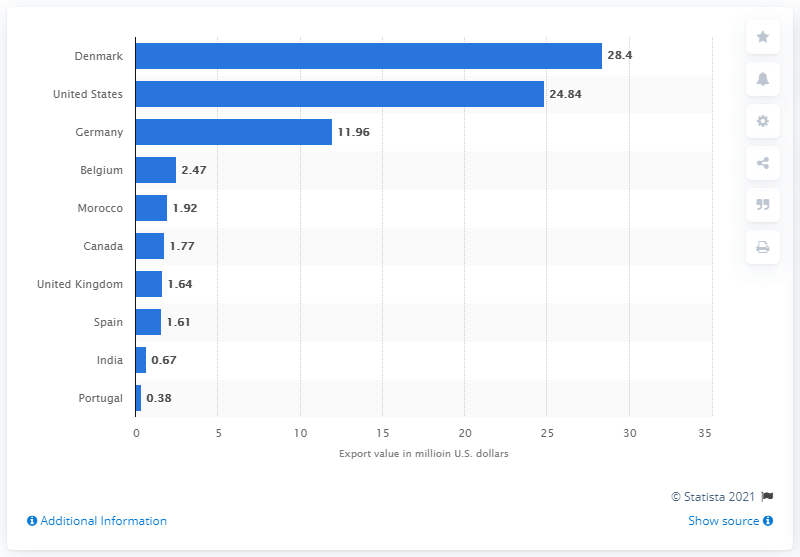Identify some key points in this picture. In 2019, the export value of Denmark's cold water shrimp and prawns was 28.4 million US dollars. 